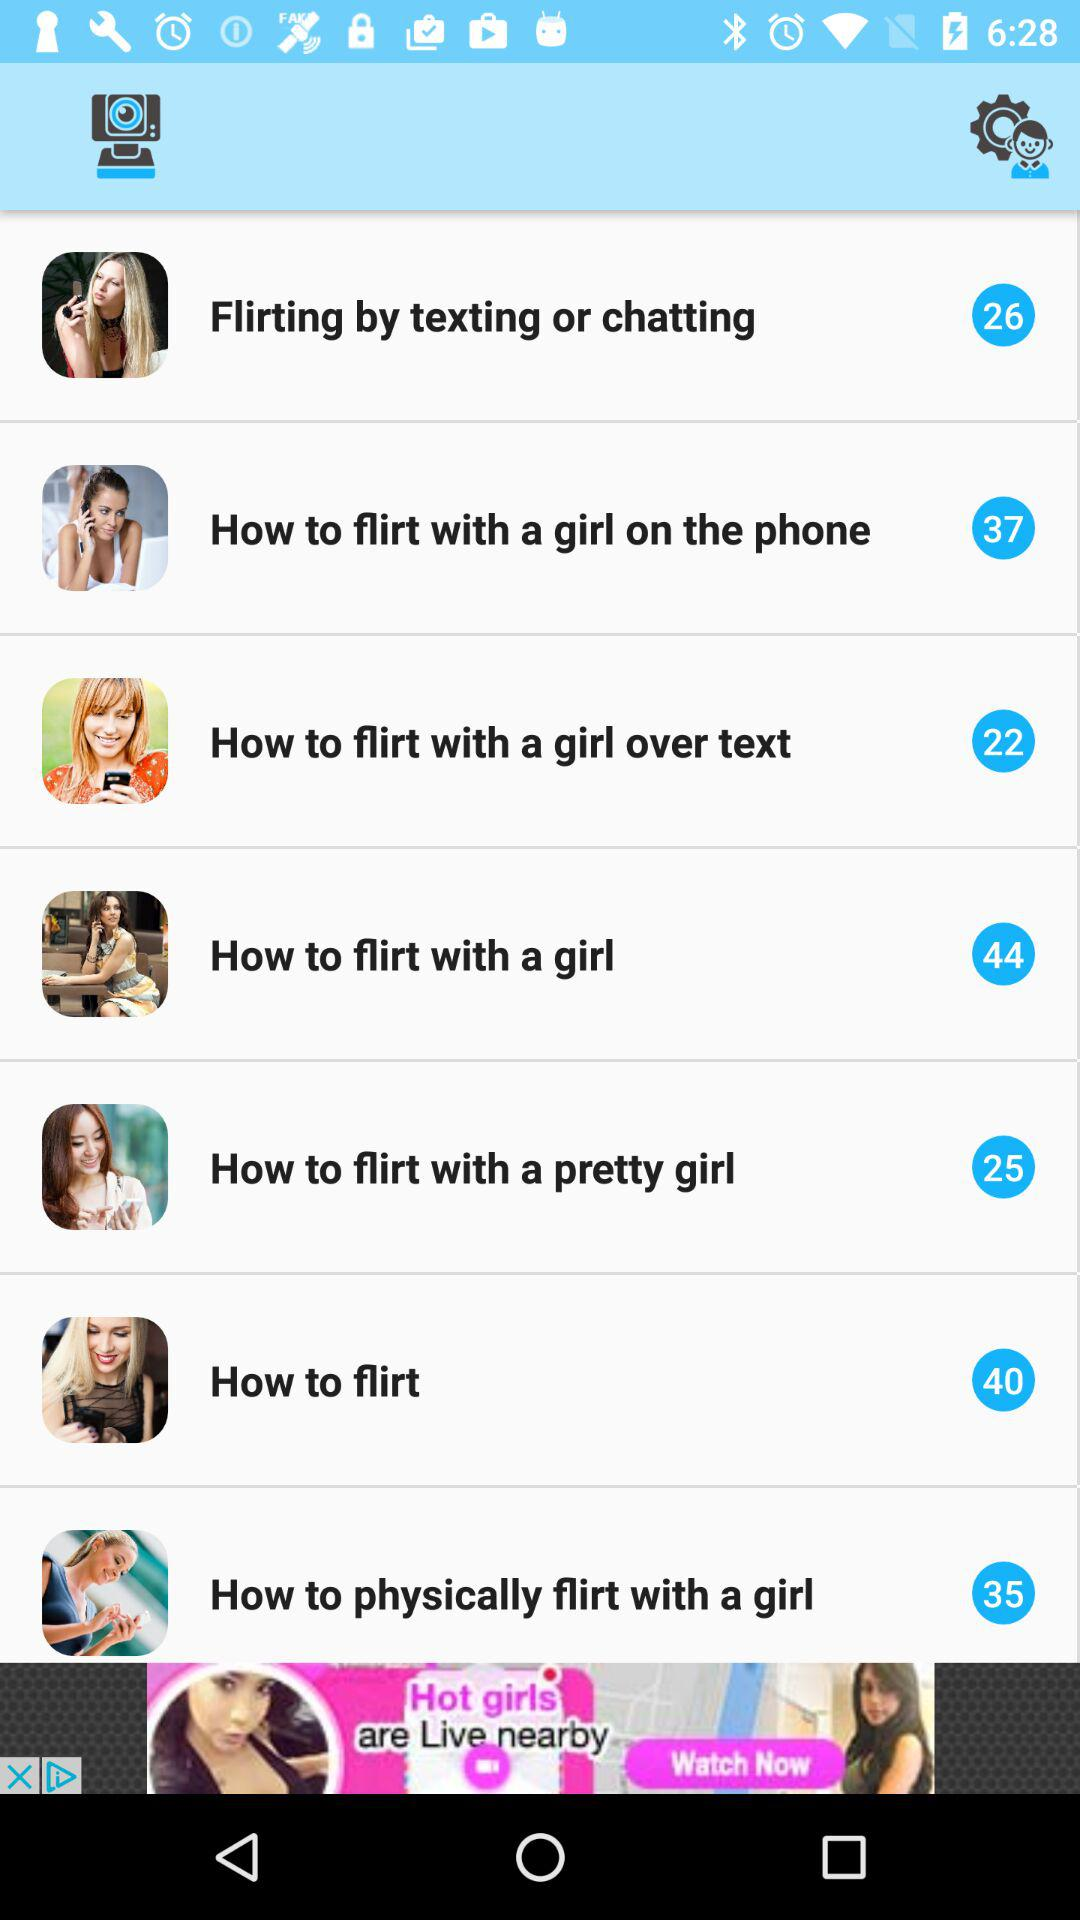What is the count of "How to flirt with a girl"? The count of "How to flirt with a girl" is 44. 